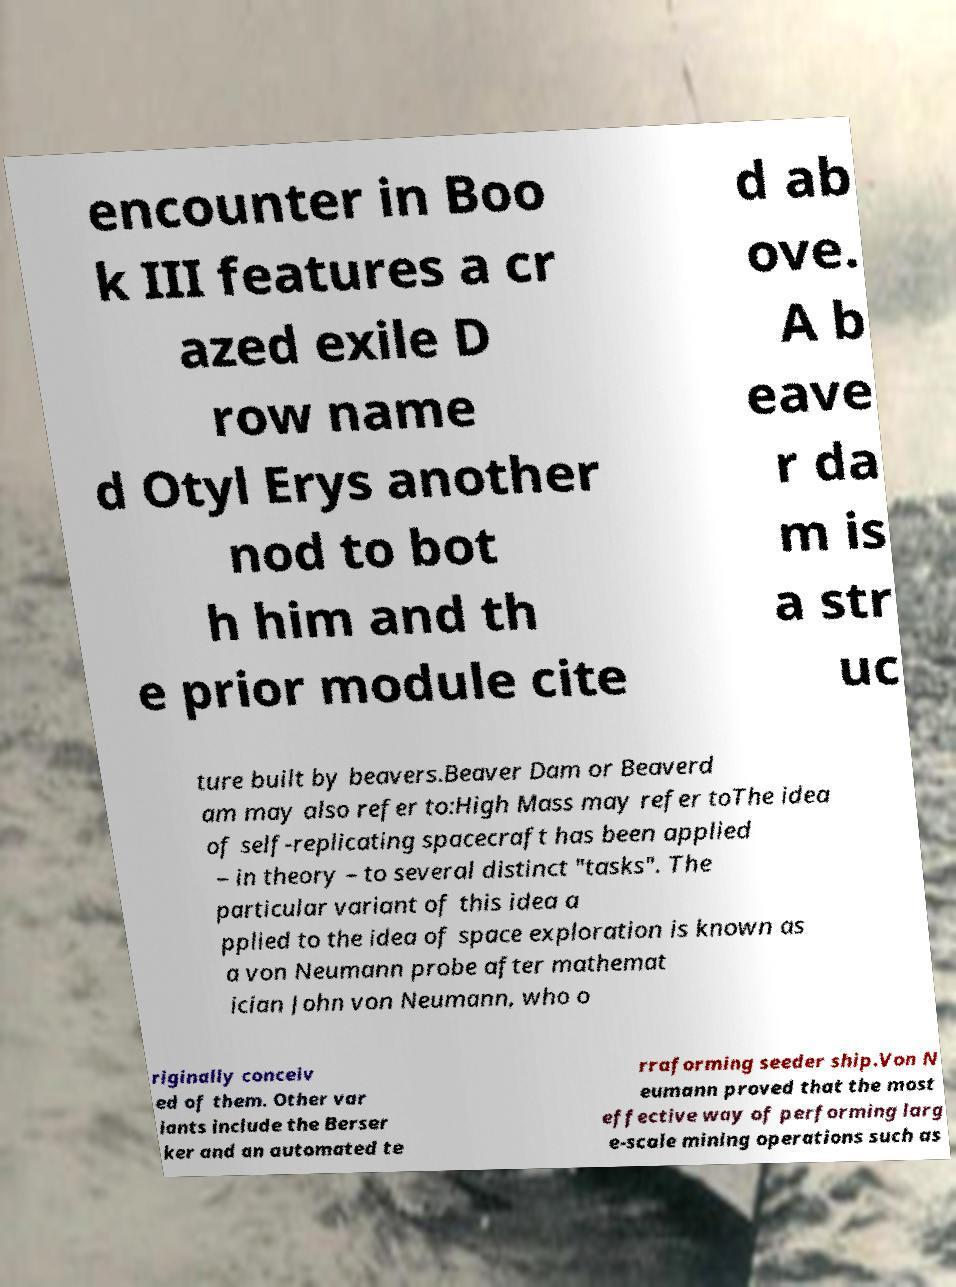Please read and relay the text visible in this image. What does it say? encounter in Boo k III features a cr azed exile D row name d Otyl Erys another nod to bot h him and th e prior module cite d ab ove. A b eave r da m is a str uc ture built by beavers.Beaver Dam or Beaverd am may also refer to:High Mass may refer toThe idea of self-replicating spacecraft has been applied – in theory – to several distinct "tasks". The particular variant of this idea a pplied to the idea of space exploration is known as a von Neumann probe after mathemat ician John von Neumann, who o riginally conceiv ed of them. Other var iants include the Berser ker and an automated te rraforming seeder ship.Von N eumann proved that the most effective way of performing larg e-scale mining operations such as 